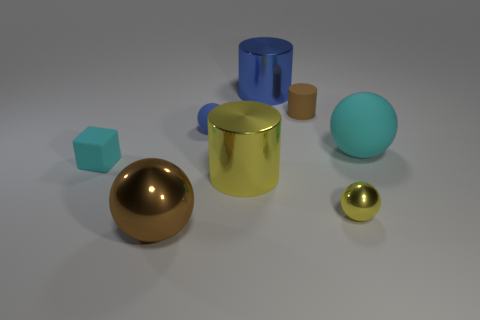Is the number of brown things right of the small yellow shiny ball less than the number of large yellow rubber blocks?
Make the answer very short. No. Is the big yellow thing made of the same material as the tiny blue sphere?
Your answer should be compact. No. The blue object that is the same shape as the big yellow shiny thing is what size?
Give a very brief answer. Large. How many things are small spheres right of the large blue shiny cylinder or small rubber objects that are left of the cyan rubber ball?
Provide a succinct answer. 4. Are there fewer cylinders than objects?
Offer a very short reply. Yes. Does the yellow metallic cylinder have the same size as the cyan rubber thing that is in front of the large cyan rubber thing?
Offer a very short reply. No. How many matte objects are either yellow balls or brown cylinders?
Give a very brief answer. 1. Is the number of big yellow things greater than the number of matte things?
Keep it short and to the point. No. The rubber sphere that is the same color as the rubber cube is what size?
Offer a terse response. Large. What shape is the brown object that is behind the cyan thing that is right of the tiny metallic sphere?
Provide a short and direct response. Cylinder. 